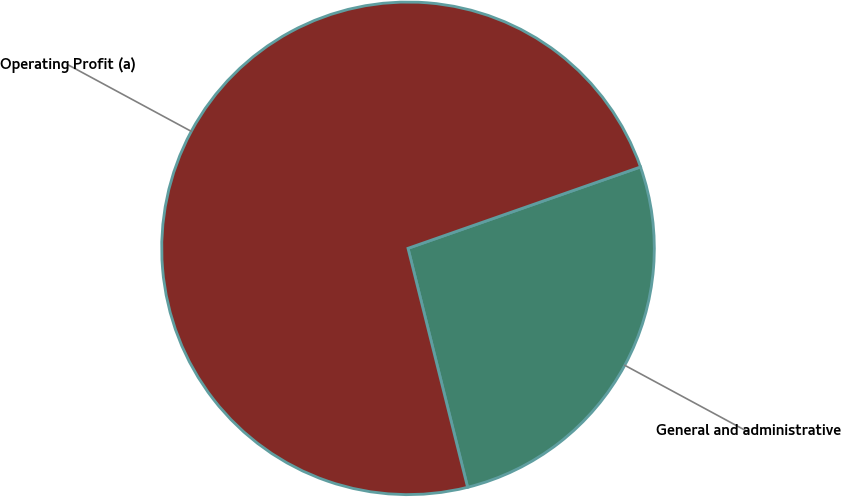Convert chart to OTSL. <chart><loc_0><loc_0><loc_500><loc_500><pie_chart><fcel>General and administrative<fcel>Operating Profit (a)<nl><fcel>26.47%<fcel>73.53%<nl></chart> 